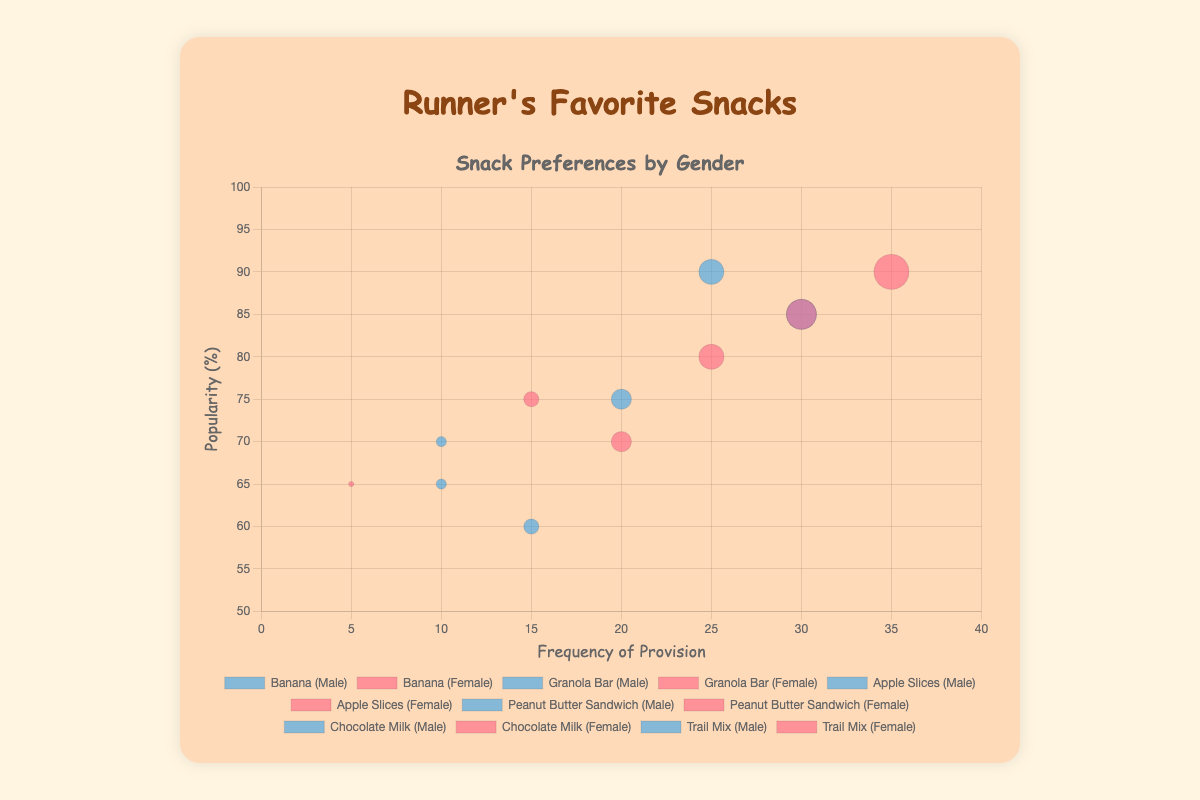What's the title of the figure? The title of the figure is displayed prominently at the top.
Answer: Runner's Favorite Snacks What are the labels of the x and y axes? The x-axis label is "Frequency of Provision" and the y-axis label is "Popularity (%)".
Answer: Frequency of Provision and Popularity (%) Which snack has the highest popularity among females? Look at the y-axis (Popularity) and identify which snack's bubble for females (in pink color) is placed highest. Chocolate Milk has the highest y-value on the female side.
Answer: Chocolate Milk How many types of snacks are displayed in the figure? Count the distinct snack types mentioned in the data. There are 6 types: Banana, Granola Bar, Apple Slices, Peanut Butter Sandwich, Chocolate Milk, and Trail Mix.
Answer: 6 For the Banana snack, which gender has a higher frequency? Compare the x-values (Frequency) of the Banana bubbles for both genders. Females have an x-value of 30, and males have an x-value of 25. Therefore, females have a higher frequency.
Answer: Female Which snack provided to males has the lowest popularity? Look at the y-axis values for the blue bubbles (males) and identify the lowest. Apple Slices has the lowest y-value at 60.
Answer: Apple Slices What is the combined frequency of Granola Bars for both genders? Sum the frequencies of Granola Bars for males (20) and females (25). 20 + 25 = 45.
Answer: 45 Which snack is least frequently provided to females? Identify the bubble (pink) with the lowest x-value for females. Peanut Butter Sandwich has the lowest frequency at 5.
Answer: Peanut Butter Sandwich Compare the popularity of Chocolate Milk between genders. Which is more popular? Compare the y-values of Chocolate Milk bubbles for both genders. Female Chocolate Milk is at 90, while male Chocolate Milk is at 85. Therefore, it's more popular among females.
Answer: Female What is the average popularity of Apple Slices for males and females? Average the popularity values of Apple Slices for both genders (Males: 60, Females: 70). (60 + 70) / 2 = 65.
Answer: 65 